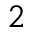<formula> <loc_0><loc_0><loc_500><loc_500>2</formula> 